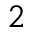<formula> <loc_0><loc_0><loc_500><loc_500>2</formula> 